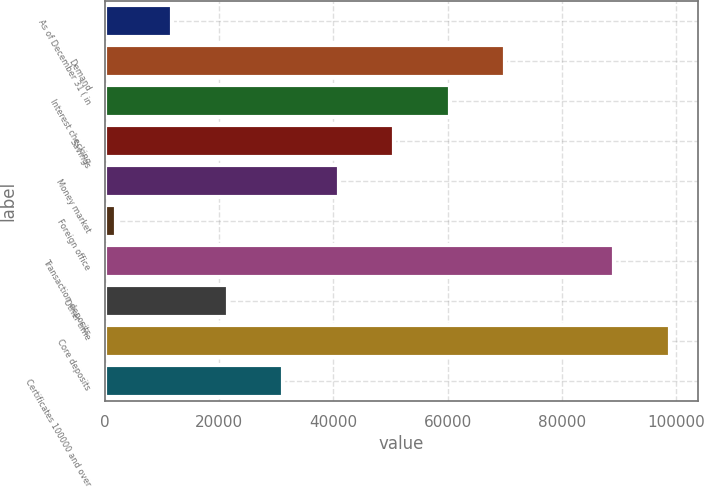<chart> <loc_0><loc_0><loc_500><loc_500><bar_chart><fcel>As of December 31 ( in<fcel>Demand<fcel>Interest checking<fcel>Savings<fcel>Money market<fcel>Foreign office<fcel>Transaction deposits<fcel>Other time<fcel>Core deposits<fcel>Certificates 100000 and over<nl><fcel>11705.9<fcel>70085.3<fcel>60355.4<fcel>50625.5<fcel>40895.6<fcel>1976<fcel>89174<fcel>21435.8<fcel>98903.9<fcel>31165.7<nl></chart> 